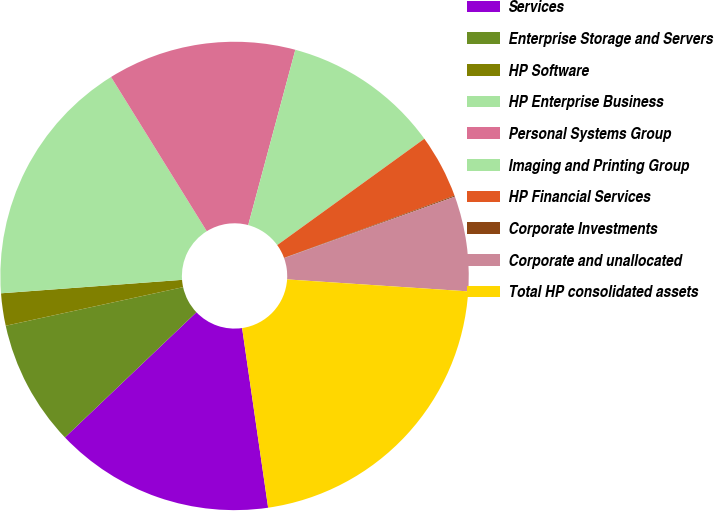Convert chart. <chart><loc_0><loc_0><loc_500><loc_500><pie_chart><fcel>Services<fcel>Enterprise Storage and Servers<fcel>HP Software<fcel>HP Enterprise Business<fcel>Personal Systems Group<fcel>Imaging and Printing Group<fcel>HP Financial Services<fcel>Corporate Investments<fcel>Corporate and unallocated<fcel>Total HP consolidated assets<nl><fcel>15.18%<fcel>8.7%<fcel>2.23%<fcel>17.34%<fcel>13.02%<fcel>10.86%<fcel>4.39%<fcel>0.07%<fcel>6.55%<fcel>21.66%<nl></chart> 